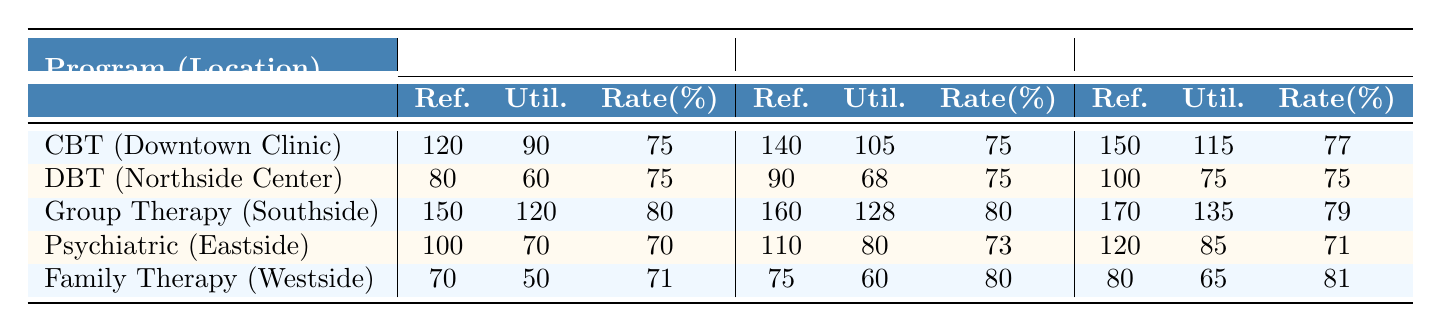What is the utilization rate for Group Therapy in 2022? The utilization rate for Group Therapy in 2022 is indicated in the table under the 2022 column, specifically in the "Rate(%)" section for Group Therapy, where it shows the value is 80%.
Answer: 80 How many clients were referred to Cognitive Behavioral Therapy (CBT) in 2021? The number of clients referred to CBT in 2021 is found in the table under the 2021 column, specifically in the "Ref." section for CBT, which shows the value is 120.
Answer: 120 Which program had the highest utilization rate in 2023? To find the highest utilization rate in 2023, we compare the utilization rates listed in that column. Group Therapy has the highest at 79%.
Answer: Group Therapy What was the change in the number of clients utilized for Family Therapy from 2021 to 2023? The number of clients utilized for Family Therapy in 2021 was 50 and in 2023 it was 65. The change is calculated by subtracting 50 from 65, resulting in a difference of 15.
Answer: 15 Is the utilization rate for Dialectical Behavior Therapy (DBT) constant over the three years? The table shows that DBT's utilization rate was 75% in all three years (2021, 2022, and 2023). Therefore, the utilization rate is constant.
Answer: Yes What is the average number of clients referred to all programs in 2022? To find the average number of clients referred in 2022, I sum the clients referred: 140 (CBT) + 90 (DBT) + 160 (Group Therapy) + 110 (Psychiatric) + 75 (Family) = 575. Then, dividing by the number of programs (5) gives: 575/5 = 115.
Answer: 115 Which program had the lowest number of clients utilized in 2023? In 2023, reviewing the "Util." (utilized) column, Psychiatric Services has the lowest number with 85 clients utilized.
Answer: Psychiatric Services What is the difference between the number of clients referred to Group Therapy and Family Therapy in 2023? The clients referred to Group Therapy is 170 and for Family Therapy, it's 80. The difference is calculated by subtracting 80 from 170, which equals 90.
Answer: 90 Did the utilization rate for Family Therapy increase from 2021 to 2023? Family Therapy's utilization rate was 71% in 2021 and increased to 81% in 2023. Since 81% is greater than 71%, it indicates an increase.
Answer: Yes What percentage did the number of clients utilized for Psychiatric Services drop from 2021 to 2023? The number of clients utilized for Psychiatric Services dropped from 70 in 2021 to 85 in 2023. To find the drop, we calculate: (70 - 85) / 70 * 100, resulting in a percentage drop of approximately 21.43%.
Answer: 21.43% 